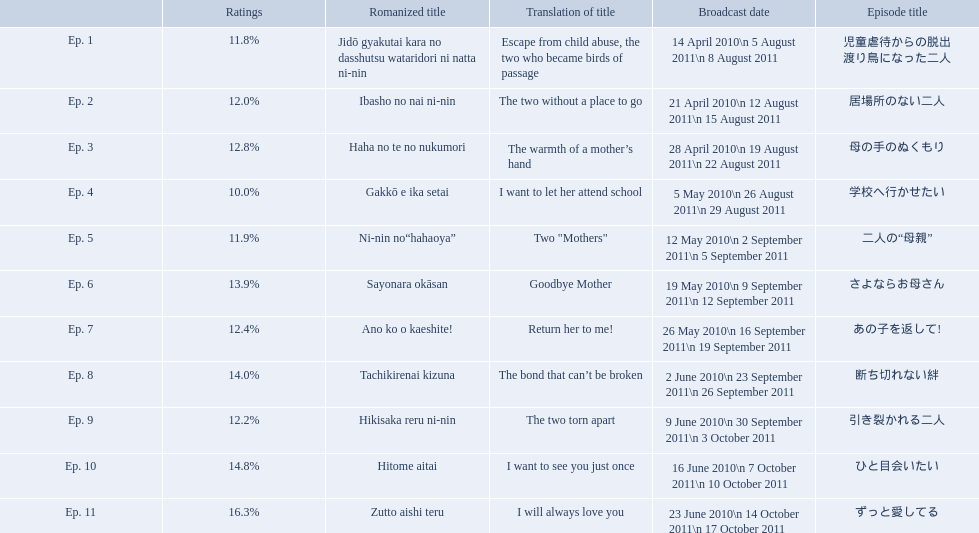What are the episode numbers? Ep. 1, Ep. 2, Ep. 3, Ep. 4, Ep. 5, Ep. 6, Ep. 7, Ep. 8, Ep. 9, Ep. 10, Ep. 11. What was the percentage of total ratings for episode 8? 14.0%. What is the name of epsiode 8? 断ち切れない絆. What were this episodes ratings? 14.0%. I'm looking to parse the entire table for insights. Could you assist me with that? {'header': ['', 'Ratings', 'Romanized title', 'Translation of title', 'Broadcast date', 'Episode title'], 'rows': [['Ep. 1', '11.8%', 'Jidō gyakutai kara no dasshutsu wataridori ni natta ni-nin', 'Escape from child abuse, the two who became birds of passage', '14 April 2010\\n 5 August 2011\\n 8 August 2011', '児童虐待からの脱出 渡り鳥になった二人'], ['Ep. 2', '12.0%', 'Ibasho no nai ni-nin', 'The two without a place to go', '21 April 2010\\n 12 August 2011\\n 15 August 2011', '居場所のない二人'], ['Ep. 3', '12.8%', 'Haha no te no nukumori', 'The warmth of a mother’s hand', '28 April 2010\\n 19 August 2011\\n 22 August 2011', '母の手のぬくもり'], ['Ep. 4', '10.0%', 'Gakkō e ika setai', 'I want to let her attend school', '5 May 2010\\n 26 August 2011\\n 29 August 2011', '学校へ行かせたい'], ['Ep. 5', '11.9%', 'Ni-nin no“hahaoya”', 'Two "Mothers"', '12 May 2010\\n 2 September 2011\\n 5 September 2011', '二人の“母親”'], ['Ep. 6', '13.9%', 'Sayonara okāsan', 'Goodbye Mother', '19 May 2010\\n 9 September 2011\\n 12 September 2011', 'さよならお母さん'], ['Ep. 7', '12.4%', 'Ano ko o kaeshite!', 'Return her to me!', '26 May 2010\\n 16 September 2011\\n 19 September 2011', 'あの子を返して!'], ['Ep. 8', '14.0%', 'Tachikirenai kizuna', 'The bond that can’t be broken', '2 June 2010\\n 23 September 2011\\n 26 September 2011', '断ち切れない絆'], ['Ep. 9', '12.2%', 'Hikisaka reru ni-nin', 'The two torn apart', '9 June 2010\\n 30 September 2011\\n 3 October 2011', '引き裂かれる二人'], ['Ep. 10', '14.8%', 'Hitome aitai', 'I want to see you just once', '16 June 2010\\n 7 October 2011\\n 10 October 2011', 'ひと目会いたい'], ['Ep. 11', '16.3%', 'Zutto aishi teru', 'I will always love you', '23 June 2010\\n 14 October 2011\\n 17 October 2011', 'ずっと愛してる']]} What are the rating percentages for each episode? 11.8%, 12.0%, 12.8%, 10.0%, 11.9%, 13.9%, 12.4%, 14.0%, 12.2%, 14.8%, 16.3%. What is the highest rating an episode got? 16.3%. What episode got a rating of 16.3%? ずっと愛してる. 